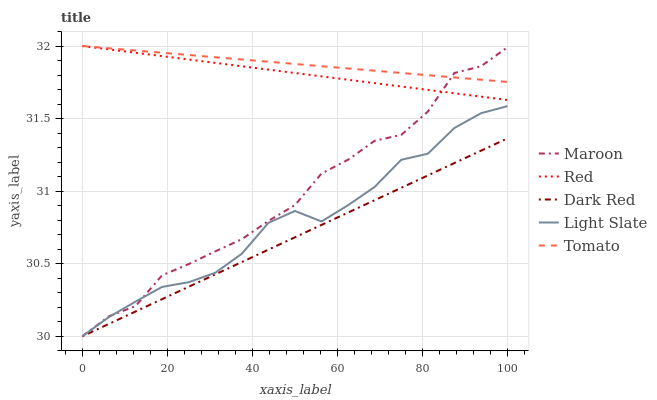Does Dark Red have the minimum area under the curve?
Answer yes or no. Yes. Does Tomato have the maximum area under the curve?
Answer yes or no. Yes. Does Tomato have the minimum area under the curve?
Answer yes or no. No. Does Dark Red have the maximum area under the curve?
Answer yes or no. No. Is Tomato the smoothest?
Answer yes or no. Yes. Is Maroon the roughest?
Answer yes or no. Yes. Is Dark Red the smoothest?
Answer yes or no. No. Is Dark Red the roughest?
Answer yes or no. No. Does Light Slate have the lowest value?
Answer yes or no. Yes. Does Tomato have the lowest value?
Answer yes or no. No. Does Red have the highest value?
Answer yes or no. Yes. Does Dark Red have the highest value?
Answer yes or no. No. Is Dark Red less than Red?
Answer yes or no. Yes. Is Tomato greater than Dark Red?
Answer yes or no. Yes. Does Maroon intersect Tomato?
Answer yes or no. Yes. Is Maroon less than Tomato?
Answer yes or no. No. Is Maroon greater than Tomato?
Answer yes or no. No. Does Dark Red intersect Red?
Answer yes or no. No. 